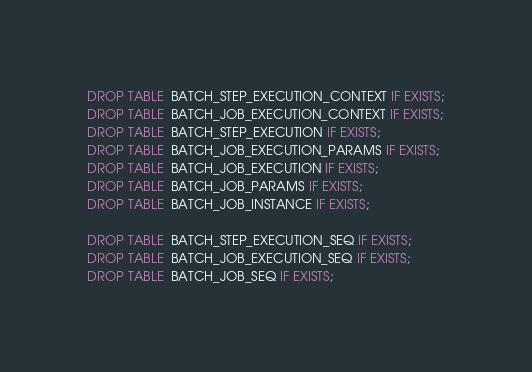<code> <loc_0><loc_0><loc_500><loc_500><_SQL_>DROP TABLE  BATCH_STEP_EXECUTION_CONTEXT IF EXISTS;
DROP TABLE  BATCH_JOB_EXECUTION_CONTEXT IF EXISTS;
DROP TABLE  BATCH_STEP_EXECUTION IF EXISTS;
DROP TABLE  BATCH_JOB_EXECUTION_PARAMS IF EXISTS;
DROP TABLE  BATCH_JOB_EXECUTION IF EXISTS;
DROP TABLE  BATCH_JOB_PARAMS IF EXISTS;
DROP TABLE  BATCH_JOB_INSTANCE IF EXISTS;

DROP TABLE  BATCH_STEP_EXECUTION_SEQ IF EXISTS;
DROP TABLE  BATCH_JOB_EXECUTION_SEQ IF EXISTS;
DROP TABLE  BATCH_JOB_SEQ IF EXISTS;</code> 